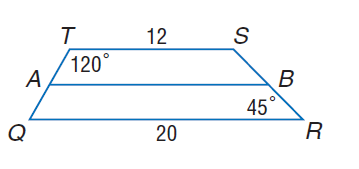Answer the mathemtical geometry problem and directly provide the correct option letter.
Question: For trapezoid Q R S T, A and B are midpoints of the legs. Find A B.
Choices: A: 12 B: 16 C: 20 D: 32 B 